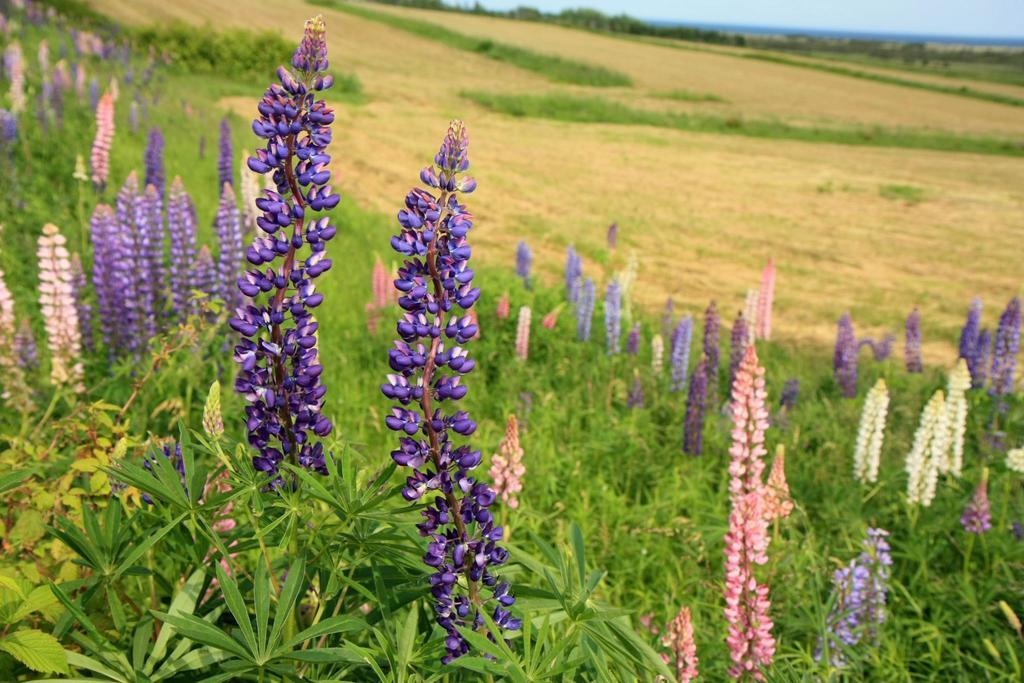What type of plants are visible in the image? There are plants with flowers in the image. Can you describe the background of the image? The background of the image is blurred. What color is the tooth in the image? There is no tooth present in the image. Is the coal visible in the image? There is no coal present in the image. 